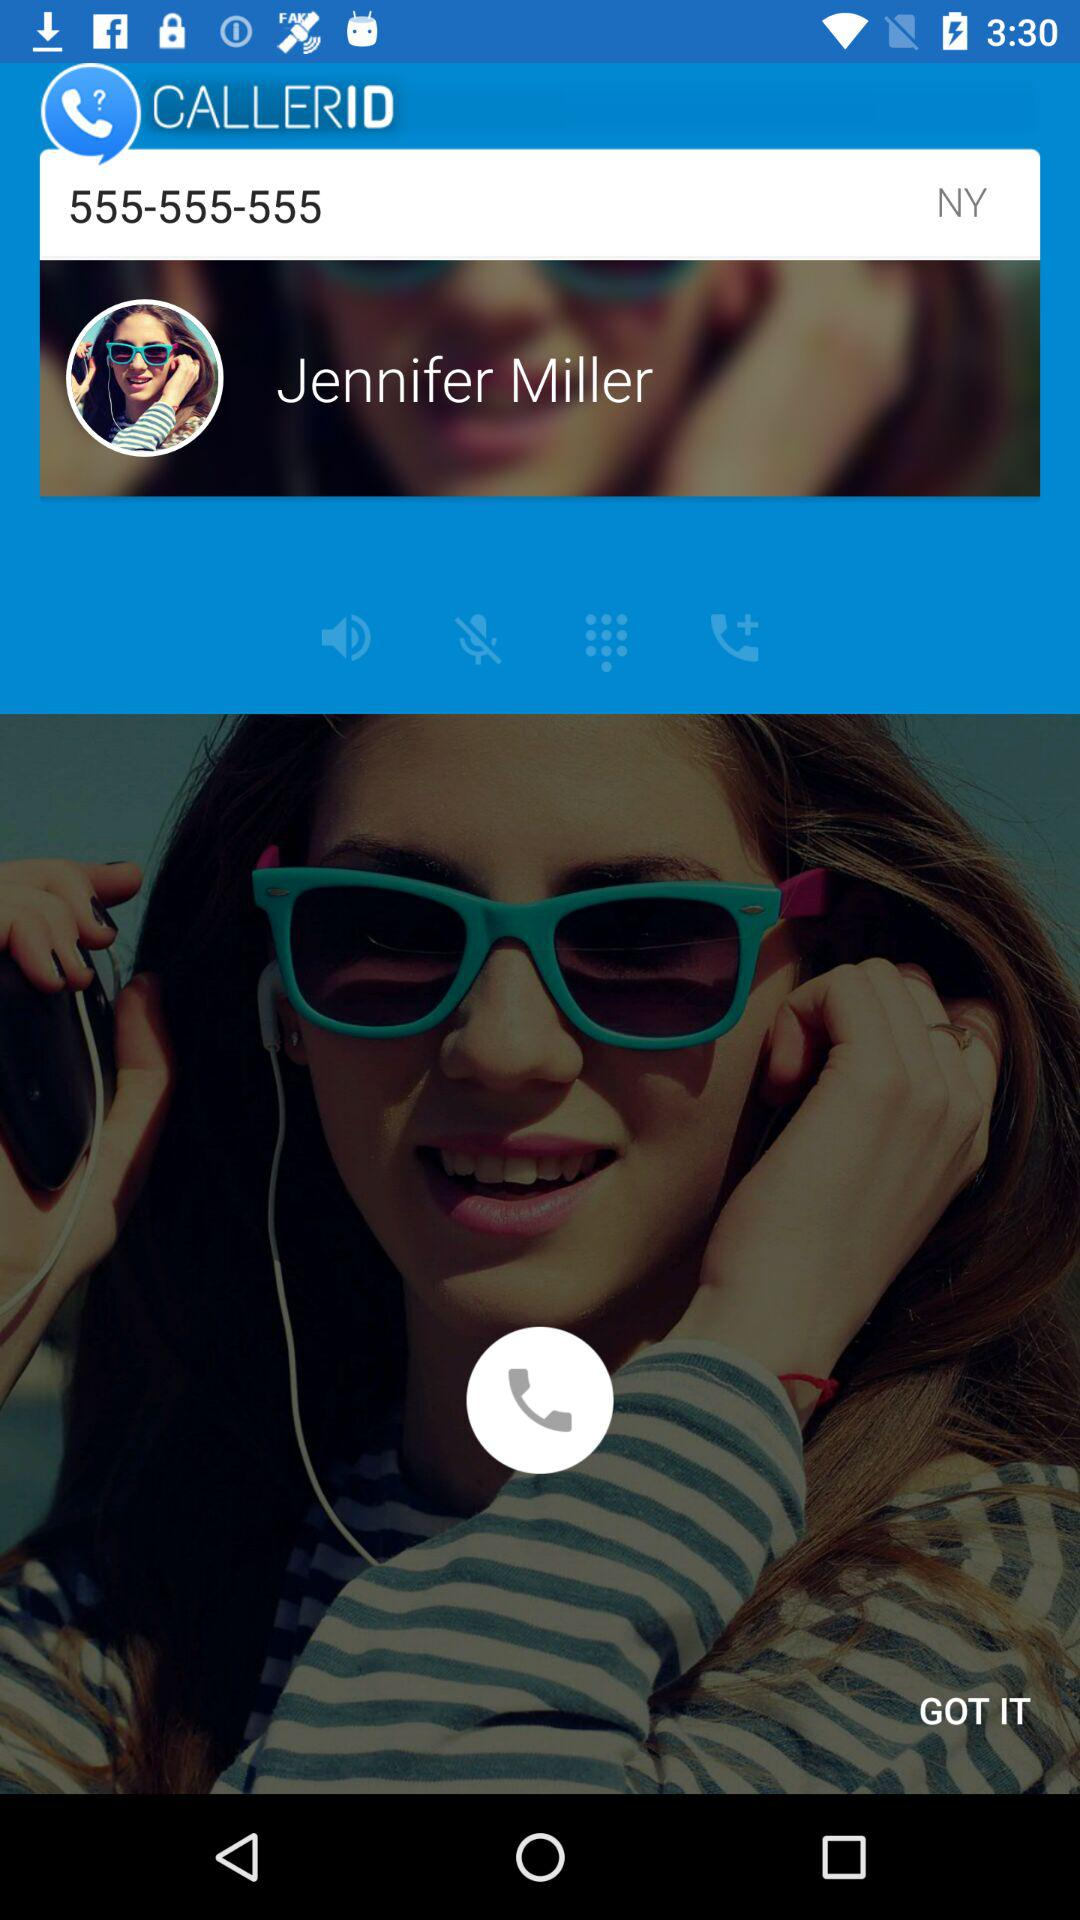From which city is the user calling?
When the provided information is insufficient, respond with <no answer>. <no answer> 